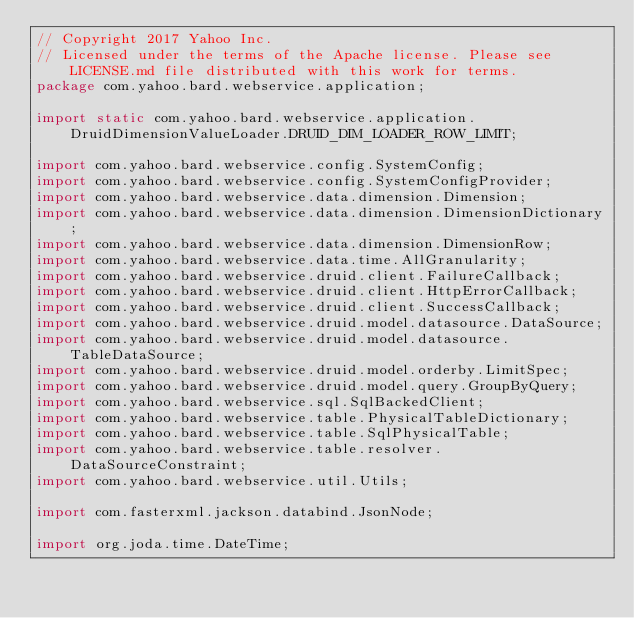Convert code to text. <code><loc_0><loc_0><loc_500><loc_500><_Java_>// Copyright 2017 Yahoo Inc.
// Licensed under the terms of the Apache license. Please see LICENSE.md file distributed with this work for terms.
package com.yahoo.bard.webservice.application;

import static com.yahoo.bard.webservice.application.DruidDimensionValueLoader.DRUID_DIM_LOADER_ROW_LIMIT;

import com.yahoo.bard.webservice.config.SystemConfig;
import com.yahoo.bard.webservice.config.SystemConfigProvider;
import com.yahoo.bard.webservice.data.dimension.Dimension;
import com.yahoo.bard.webservice.data.dimension.DimensionDictionary;
import com.yahoo.bard.webservice.data.dimension.DimensionRow;
import com.yahoo.bard.webservice.data.time.AllGranularity;
import com.yahoo.bard.webservice.druid.client.FailureCallback;
import com.yahoo.bard.webservice.druid.client.HttpErrorCallback;
import com.yahoo.bard.webservice.druid.client.SuccessCallback;
import com.yahoo.bard.webservice.druid.model.datasource.DataSource;
import com.yahoo.bard.webservice.druid.model.datasource.TableDataSource;
import com.yahoo.bard.webservice.druid.model.orderby.LimitSpec;
import com.yahoo.bard.webservice.druid.model.query.GroupByQuery;
import com.yahoo.bard.webservice.sql.SqlBackedClient;
import com.yahoo.bard.webservice.table.PhysicalTableDictionary;
import com.yahoo.bard.webservice.table.SqlPhysicalTable;
import com.yahoo.bard.webservice.table.resolver.DataSourceConstraint;
import com.yahoo.bard.webservice.util.Utils;

import com.fasterxml.jackson.databind.JsonNode;

import org.joda.time.DateTime;</code> 